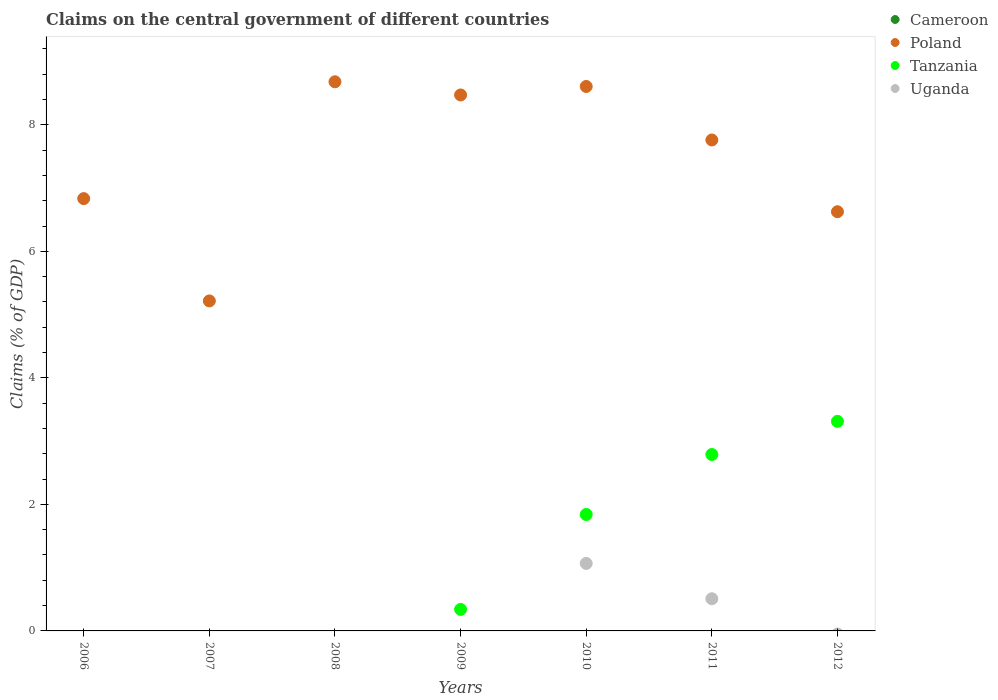How many different coloured dotlines are there?
Provide a succinct answer. 3. Is the number of dotlines equal to the number of legend labels?
Give a very brief answer. No. What is the percentage of GDP claimed on the central government in Tanzania in 2012?
Ensure brevity in your answer.  3.31. Across all years, what is the maximum percentage of GDP claimed on the central government in Tanzania?
Offer a very short reply. 3.31. Across all years, what is the minimum percentage of GDP claimed on the central government in Cameroon?
Provide a succinct answer. 0. What is the total percentage of GDP claimed on the central government in Uganda in the graph?
Keep it short and to the point. 1.58. What is the difference between the percentage of GDP claimed on the central government in Poland in 2006 and that in 2009?
Offer a terse response. -1.64. What is the difference between the percentage of GDP claimed on the central government in Cameroon in 2011 and the percentage of GDP claimed on the central government in Poland in 2008?
Keep it short and to the point. -8.68. In the year 2011, what is the difference between the percentage of GDP claimed on the central government in Poland and percentage of GDP claimed on the central government in Tanzania?
Offer a very short reply. 4.97. In how many years, is the percentage of GDP claimed on the central government in Tanzania greater than 8.8 %?
Your answer should be compact. 0. What is the ratio of the percentage of GDP claimed on the central government in Poland in 2006 to that in 2007?
Provide a succinct answer. 1.31. Is the percentage of GDP claimed on the central government in Poland in 2007 less than that in 2010?
Your response must be concise. Yes. Is the difference between the percentage of GDP claimed on the central government in Poland in 2010 and 2012 greater than the difference between the percentage of GDP claimed on the central government in Tanzania in 2010 and 2012?
Offer a terse response. Yes. What is the difference between the highest and the second highest percentage of GDP claimed on the central government in Poland?
Provide a succinct answer. 0.07. What is the difference between the highest and the lowest percentage of GDP claimed on the central government in Tanzania?
Provide a succinct answer. 3.31. In how many years, is the percentage of GDP claimed on the central government in Poland greater than the average percentage of GDP claimed on the central government in Poland taken over all years?
Your response must be concise. 4. Is the sum of the percentage of GDP claimed on the central government in Poland in 2006 and 2012 greater than the maximum percentage of GDP claimed on the central government in Tanzania across all years?
Provide a succinct answer. Yes. Is it the case that in every year, the sum of the percentage of GDP claimed on the central government in Cameroon and percentage of GDP claimed on the central government in Tanzania  is greater than the percentage of GDP claimed on the central government in Poland?
Offer a very short reply. No. Is the percentage of GDP claimed on the central government in Uganda strictly greater than the percentage of GDP claimed on the central government in Tanzania over the years?
Offer a very short reply. No. Is the percentage of GDP claimed on the central government in Poland strictly less than the percentage of GDP claimed on the central government in Uganda over the years?
Offer a very short reply. No. What is the difference between two consecutive major ticks on the Y-axis?
Provide a short and direct response. 2. Does the graph contain grids?
Your response must be concise. No. Where does the legend appear in the graph?
Make the answer very short. Top right. How many legend labels are there?
Your response must be concise. 4. What is the title of the graph?
Offer a very short reply. Claims on the central government of different countries. What is the label or title of the X-axis?
Provide a succinct answer. Years. What is the label or title of the Y-axis?
Provide a succinct answer. Claims (% of GDP). What is the Claims (% of GDP) in Poland in 2006?
Keep it short and to the point. 6.83. What is the Claims (% of GDP) of Tanzania in 2006?
Give a very brief answer. 0. What is the Claims (% of GDP) in Uganda in 2006?
Make the answer very short. 0. What is the Claims (% of GDP) in Poland in 2007?
Keep it short and to the point. 5.22. What is the Claims (% of GDP) of Poland in 2008?
Offer a very short reply. 8.68. What is the Claims (% of GDP) in Cameroon in 2009?
Give a very brief answer. 0. What is the Claims (% of GDP) in Poland in 2009?
Provide a succinct answer. 8.47. What is the Claims (% of GDP) in Tanzania in 2009?
Offer a very short reply. 0.34. What is the Claims (% of GDP) in Uganda in 2009?
Ensure brevity in your answer.  0. What is the Claims (% of GDP) of Cameroon in 2010?
Ensure brevity in your answer.  0. What is the Claims (% of GDP) of Poland in 2010?
Make the answer very short. 8.61. What is the Claims (% of GDP) of Tanzania in 2010?
Offer a very short reply. 1.84. What is the Claims (% of GDP) in Uganda in 2010?
Give a very brief answer. 1.07. What is the Claims (% of GDP) of Cameroon in 2011?
Offer a very short reply. 0. What is the Claims (% of GDP) in Poland in 2011?
Your answer should be very brief. 7.76. What is the Claims (% of GDP) in Tanzania in 2011?
Your answer should be compact. 2.79. What is the Claims (% of GDP) in Uganda in 2011?
Provide a succinct answer. 0.51. What is the Claims (% of GDP) of Cameroon in 2012?
Keep it short and to the point. 0. What is the Claims (% of GDP) of Poland in 2012?
Provide a short and direct response. 6.63. What is the Claims (% of GDP) of Tanzania in 2012?
Provide a succinct answer. 3.31. Across all years, what is the maximum Claims (% of GDP) of Poland?
Ensure brevity in your answer.  8.68. Across all years, what is the maximum Claims (% of GDP) in Tanzania?
Your answer should be compact. 3.31. Across all years, what is the maximum Claims (% of GDP) of Uganda?
Provide a succinct answer. 1.07. Across all years, what is the minimum Claims (% of GDP) in Poland?
Provide a succinct answer. 5.22. Across all years, what is the minimum Claims (% of GDP) in Tanzania?
Your answer should be very brief. 0. Across all years, what is the minimum Claims (% of GDP) in Uganda?
Give a very brief answer. 0. What is the total Claims (% of GDP) of Cameroon in the graph?
Your response must be concise. 0. What is the total Claims (% of GDP) in Poland in the graph?
Your response must be concise. 52.19. What is the total Claims (% of GDP) in Tanzania in the graph?
Your answer should be very brief. 8.28. What is the total Claims (% of GDP) of Uganda in the graph?
Provide a succinct answer. 1.58. What is the difference between the Claims (% of GDP) of Poland in 2006 and that in 2007?
Offer a terse response. 1.62. What is the difference between the Claims (% of GDP) of Poland in 2006 and that in 2008?
Offer a terse response. -1.85. What is the difference between the Claims (% of GDP) in Poland in 2006 and that in 2009?
Give a very brief answer. -1.64. What is the difference between the Claims (% of GDP) of Poland in 2006 and that in 2010?
Your answer should be compact. -1.77. What is the difference between the Claims (% of GDP) in Poland in 2006 and that in 2011?
Offer a terse response. -0.93. What is the difference between the Claims (% of GDP) of Poland in 2006 and that in 2012?
Make the answer very short. 0.21. What is the difference between the Claims (% of GDP) of Poland in 2007 and that in 2008?
Keep it short and to the point. -3.46. What is the difference between the Claims (% of GDP) of Poland in 2007 and that in 2009?
Give a very brief answer. -3.26. What is the difference between the Claims (% of GDP) in Poland in 2007 and that in 2010?
Your answer should be compact. -3.39. What is the difference between the Claims (% of GDP) of Poland in 2007 and that in 2011?
Your answer should be compact. -2.54. What is the difference between the Claims (% of GDP) in Poland in 2007 and that in 2012?
Offer a terse response. -1.41. What is the difference between the Claims (% of GDP) in Poland in 2008 and that in 2009?
Your answer should be very brief. 0.21. What is the difference between the Claims (% of GDP) of Poland in 2008 and that in 2010?
Give a very brief answer. 0.07. What is the difference between the Claims (% of GDP) of Poland in 2008 and that in 2011?
Make the answer very short. 0.92. What is the difference between the Claims (% of GDP) of Poland in 2008 and that in 2012?
Make the answer very short. 2.05. What is the difference between the Claims (% of GDP) in Poland in 2009 and that in 2010?
Give a very brief answer. -0.13. What is the difference between the Claims (% of GDP) of Poland in 2009 and that in 2011?
Make the answer very short. 0.71. What is the difference between the Claims (% of GDP) in Tanzania in 2009 and that in 2011?
Ensure brevity in your answer.  -2.45. What is the difference between the Claims (% of GDP) in Poland in 2009 and that in 2012?
Provide a succinct answer. 1.85. What is the difference between the Claims (% of GDP) of Tanzania in 2009 and that in 2012?
Your response must be concise. -2.97. What is the difference between the Claims (% of GDP) of Poland in 2010 and that in 2011?
Offer a terse response. 0.85. What is the difference between the Claims (% of GDP) of Tanzania in 2010 and that in 2011?
Your answer should be compact. -0.95. What is the difference between the Claims (% of GDP) of Uganda in 2010 and that in 2011?
Provide a short and direct response. 0.56. What is the difference between the Claims (% of GDP) of Poland in 2010 and that in 2012?
Your answer should be very brief. 1.98. What is the difference between the Claims (% of GDP) in Tanzania in 2010 and that in 2012?
Offer a very short reply. -1.47. What is the difference between the Claims (% of GDP) in Poland in 2011 and that in 2012?
Provide a succinct answer. 1.13. What is the difference between the Claims (% of GDP) of Tanzania in 2011 and that in 2012?
Provide a succinct answer. -0.52. What is the difference between the Claims (% of GDP) in Poland in 2006 and the Claims (% of GDP) in Tanzania in 2009?
Give a very brief answer. 6.49. What is the difference between the Claims (% of GDP) of Poland in 2006 and the Claims (% of GDP) of Tanzania in 2010?
Your response must be concise. 4.99. What is the difference between the Claims (% of GDP) of Poland in 2006 and the Claims (% of GDP) of Uganda in 2010?
Provide a succinct answer. 5.77. What is the difference between the Claims (% of GDP) of Poland in 2006 and the Claims (% of GDP) of Tanzania in 2011?
Offer a terse response. 4.04. What is the difference between the Claims (% of GDP) in Poland in 2006 and the Claims (% of GDP) in Uganda in 2011?
Provide a succinct answer. 6.32. What is the difference between the Claims (% of GDP) in Poland in 2006 and the Claims (% of GDP) in Tanzania in 2012?
Keep it short and to the point. 3.52. What is the difference between the Claims (% of GDP) of Poland in 2007 and the Claims (% of GDP) of Tanzania in 2009?
Keep it short and to the point. 4.88. What is the difference between the Claims (% of GDP) of Poland in 2007 and the Claims (% of GDP) of Tanzania in 2010?
Give a very brief answer. 3.38. What is the difference between the Claims (% of GDP) of Poland in 2007 and the Claims (% of GDP) of Uganda in 2010?
Keep it short and to the point. 4.15. What is the difference between the Claims (% of GDP) in Poland in 2007 and the Claims (% of GDP) in Tanzania in 2011?
Keep it short and to the point. 2.43. What is the difference between the Claims (% of GDP) in Poland in 2007 and the Claims (% of GDP) in Uganda in 2011?
Offer a terse response. 4.71. What is the difference between the Claims (% of GDP) of Poland in 2007 and the Claims (% of GDP) of Tanzania in 2012?
Provide a succinct answer. 1.9. What is the difference between the Claims (% of GDP) in Poland in 2008 and the Claims (% of GDP) in Tanzania in 2009?
Provide a succinct answer. 8.34. What is the difference between the Claims (% of GDP) of Poland in 2008 and the Claims (% of GDP) of Tanzania in 2010?
Your answer should be very brief. 6.84. What is the difference between the Claims (% of GDP) in Poland in 2008 and the Claims (% of GDP) in Uganda in 2010?
Your response must be concise. 7.61. What is the difference between the Claims (% of GDP) in Poland in 2008 and the Claims (% of GDP) in Tanzania in 2011?
Give a very brief answer. 5.89. What is the difference between the Claims (% of GDP) of Poland in 2008 and the Claims (% of GDP) of Uganda in 2011?
Provide a short and direct response. 8.17. What is the difference between the Claims (% of GDP) of Poland in 2008 and the Claims (% of GDP) of Tanzania in 2012?
Your response must be concise. 5.37. What is the difference between the Claims (% of GDP) of Poland in 2009 and the Claims (% of GDP) of Tanzania in 2010?
Your answer should be very brief. 6.63. What is the difference between the Claims (% of GDP) in Poland in 2009 and the Claims (% of GDP) in Uganda in 2010?
Ensure brevity in your answer.  7.4. What is the difference between the Claims (% of GDP) in Tanzania in 2009 and the Claims (% of GDP) in Uganda in 2010?
Your answer should be very brief. -0.73. What is the difference between the Claims (% of GDP) of Poland in 2009 and the Claims (% of GDP) of Tanzania in 2011?
Give a very brief answer. 5.68. What is the difference between the Claims (% of GDP) in Poland in 2009 and the Claims (% of GDP) in Uganda in 2011?
Your response must be concise. 7.96. What is the difference between the Claims (% of GDP) of Tanzania in 2009 and the Claims (% of GDP) of Uganda in 2011?
Your answer should be very brief. -0.17. What is the difference between the Claims (% of GDP) in Poland in 2009 and the Claims (% of GDP) in Tanzania in 2012?
Your response must be concise. 5.16. What is the difference between the Claims (% of GDP) in Poland in 2010 and the Claims (% of GDP) in Tanzania in 2011?
Ensure brevity in your answer.  5.82. What is the difference between the Claims (% of GDP) in Poland in 2010 and the Claims (% of GDP) in Uganda in 2011?
Ensure brevity in your answer.  8.1. What is the difference between the Claims (% of GDP) in Tanzania in 2010 and the Claims (% of GDP) in Uganda in 2011?
Offer a very short reply. 1.33. What is the difference between the Claims (% of GDP) of Poland in 2010 and the Claims (% of GDP) of Tanzania in 2012?
Offer a terse response. 5.29. What is the difference between the Claims (% of GDP) of Poland in 2011 and the Claims (% of GDP) of Tanzania in 2012?
Your answer should be very brief. 4.45. What is the average Claims (% of GDP) in Poland per year?
Give a very brief answer. 7.46. What is the average Claims (% of GDP) in Tanzania per year?
Keep it short and to the point. 1.18. What is the average Claims (% of GDP) of Uganda per year?
Offer a terse response. 0.23. In the year 2009, what is the difference between the Claims (% of GDP) in Poland and Claims (% of GDP) in Tanzania?
Make the answer very short. 8.13. In the year 2010, what is the difference between the Claims (% of GDP) of Poland and Claims (% of GDP) of Tanzania?
Make the answer very short. 6.77. In the year 2010, what is the difference between the Claims (% of GDP) in Poland and Claims (% of GDP) in Uganda?
Give a very brief answer. 7.54. In the year 2010, what is the difference between the Claims (% of GDP) in Tanzania and Claims (% of GDP) in Uganda?
Offer a very short reply. 0.77. In the year 2011, what is the difference between the Claims (% of GDP) of Poland and Claims (% of GDP) of Tanzania?
Provide a short and direct response. 4.97. In the year 2011, what is the difference between the Claims (% of GDP) in Poland and Claims (% of GDP) in Uganda?
Offer a terse response. 7.25. In the year 2011, what is the difference between the Claims (% of GDP) in Tanzania and Claims (% of GDP) in Uganda?
Ensure brevity in your answer.  2.28. In the year 2012, what is the difference between the Claims (% of GDP) of Poland and Claims (% of GDP) of Tanzania?
Offer a very short reply. 3.31. What is the ratio of the Claims (% of GDP) in Poland in 2006 to that in 2007?
Ensure brevity in your answer.  1.31. What is the ratio of the Claims (% of GDP) in Poland in 2006 to that in 2008?
Ensure brevity in your answer.  0.79. What is the ratio of the Claims (% of GDP) of Poland in 2006 to that in 2009?
Give a very brief answer. 0.81. What is the ratio of the Claims (% of GDP) of Poland in 2006 to that in 2010?
Give a very brief answer. 0.79. What is the ratio of the Claims (% of GDP) in Poland in 2006 to that in 2011?
Ensure brevity in your answer.  0.88. What is the ratio of the Claims (% of GDP) of Poland in 2006 to that in 2012?
Make the answer very short. 1.03. What is the ratio of the Claims (% of GDP) of Poland in 2007 to that in 2008?
Ensure brevity in your answer.  0.6. What is the ratio of the Claims (% of GDP) in Poland in 2007 to that in 2009?
Provide a short and direct response. 0.62. What is the ratio of the Claims (% of GDP) of Poland in 2007 to that in 2010?
Ensure brevity in your answer.  0.61. What is the ratio of the Claims (% of GDP) of Poland in 2007 to that in 2011?
Provide a short and direct response. 0.67. What is the ratio of the Claims (% of GDP) in Poland in 2007 to that in 2012?
Provide a short and direct response. 0.79. What is the ratio of the Claims (% of GDP) of Poland in 2008 to that in 2009?
Your response must be concise. 1.02. What is the ratio of the Claims (% of GDP) of Poland in 2008 to that in 2010?
Your answer should be compact. 1.01. What is the ratio of the Claims (% of GDP) of Poland in 2008 to that in 2011?
Your response must be concise. 1.12. What is the ratio of the Claims (% of GDP) of Poland in 2008 to that in 2012?
Give a very brief answer. 1.31. What is the ratio of the Claims (% of GDP) of Poland in 2009 to that in 2010?
Offer a terse response. 0.98. What is the ratio of the Claims (% of GDP) of Tanzania in 2009 to that in 2010?
Make the answer very short. 0.18. What is the ratio of the Claims (% of GDP) of Poland in 2009 to that in 2011?
Your answer should be compact. 1.09. What is the ratio of the Claims (% of GDP) in Tanzania in 2009 to that in 2011?
Your answer should be very brief. 0.12. What is the ratio of the Claims (% of GDP) in Poland in 2009 to that in 2012?
Provide a short and direct response. 1.28. What is the ratio of the Claims (% of GDP) in Tanzania in 2009 to that in 2012?
Offer a very short reply. 0.1. What is the ratio of the Claims (% of GDP) of Poland in 2010 to that in 2011?
Your response must be concise. 1.11. What is the ratio of the Claims (% of GDP) in Tanzania in 2010 to that in 2011?
Ensure brevity in your answer.  0.66. What is the ratio of the Claims (% of GDP) in Uganda in 2010 to that in 2011?
Keep it short and to the point. 2.1. What is the ratio of the Claims (% of GDP) in Poland in 2010 to that in 2012?
Ensure brevity in your answer.  1.3. What is the ratio of the Claims (% of GDP) in Tanzania in 2010 to that in 2012?
Make the answer very short. 0.56. What is the ratio of the Claims (% of GDP) of Poland in 2011 to that in 2012?
Provide a short and direct response. 1.17. What is the ratio of the Claims (% of GDP) in Tanzania in 2011 to that in 2012?
Your answer should be very brief. 0.84. What is the difference between the highest and the second highest Claims (% of GDP) in Poland?
Provide a short and direct response. 0.07. What is the difference between the highest and the second highest Claims (% of GDP) in Tanzania?
Give a very brief answer. 0.52. What is the difference between the highest and the lowest Claims (% of GDP) in Poland?
Offer a terse response. 3.46. What is the difference between the highest and the lowest Claims (% of GDP) in Tanzania?
Provide a short and direct response. 3.31. What is the difference between the highest and the lowest Claims (% of GDP) of Uganda?
Provide a succinct answer. 1.07. 